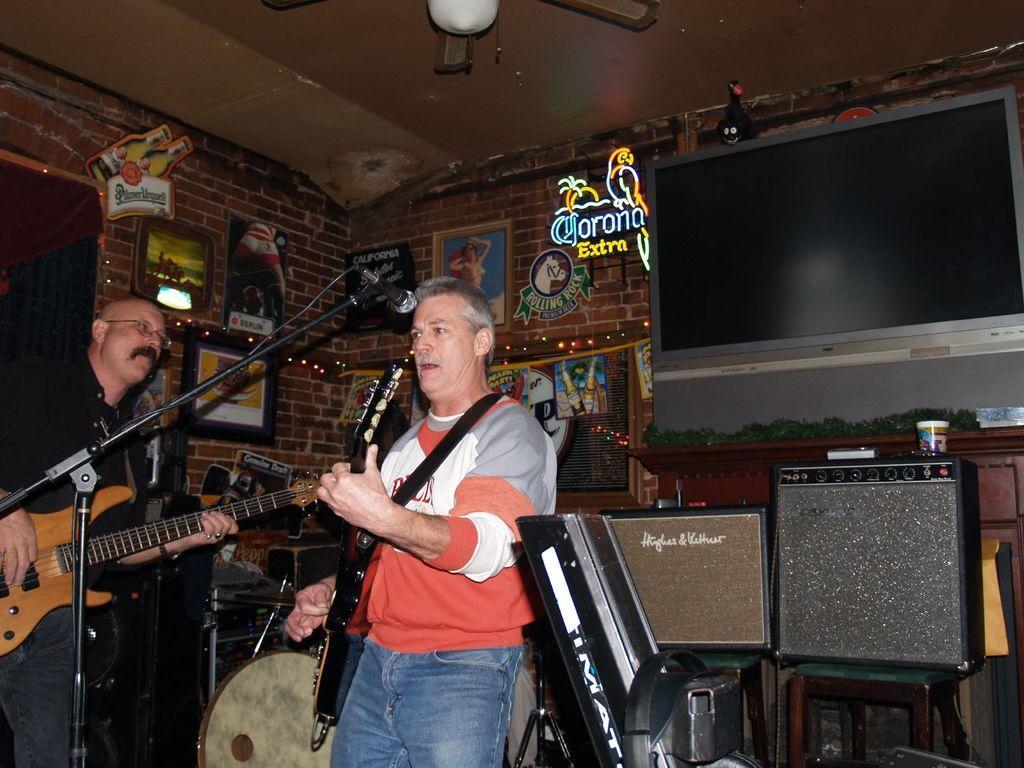Describe this image in one or two sentences. It is a concert there are two men in the picture, both of them are holding guitars in the hand, to the right side there are two stools and there are some equipment on them, in the background there is a cupboard and upon the cupboard there is a television, to the left side there is a brick wall and to the brick wall there are few photo frames stick to the wall. 